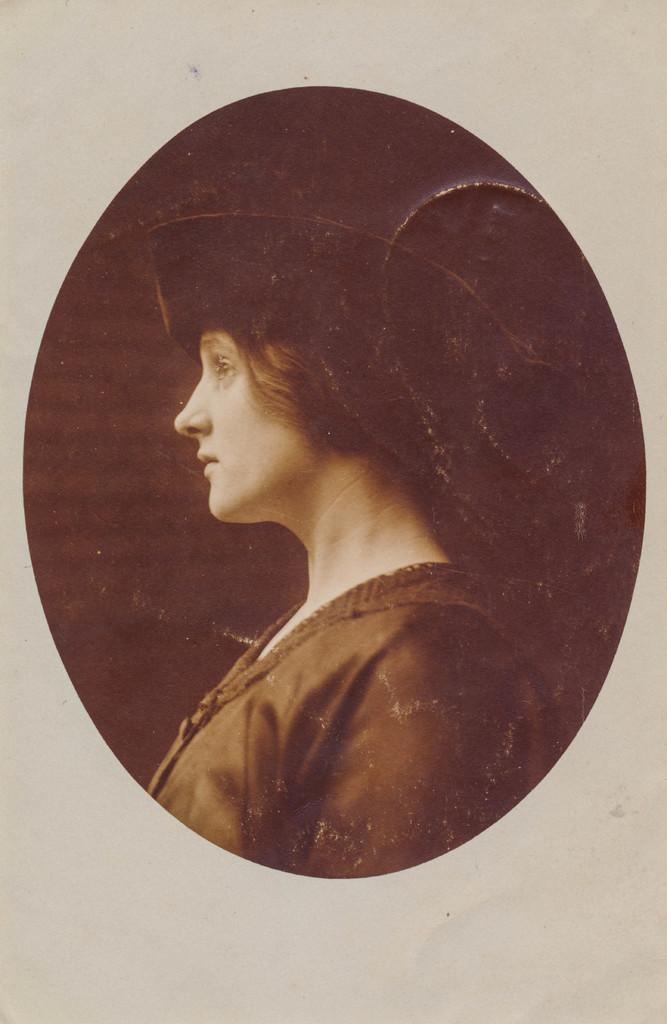What is the main subject of the image? There is a photo of a woman in the image. What color is the background of the image? The background of the image is white. What type of committee is shown in the image? There is no committee present in the image; it features a photo of a woman with a white background. Can you provide an example of a train in the image? There is no train present in the image. 